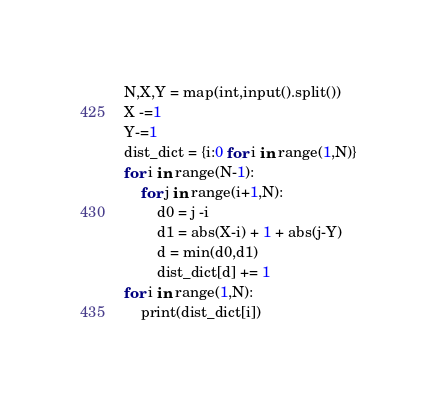<code> <loc_0><loc_0><loc_500><loc_500><_Python_>N,X,Y = map(int,input().split())
X -=1
Y-=1
dist_dict = {i:0 for i in range(1,N)}
for i in range(N-1):
    for j in range(i+1,N):
        d0 = j -i
        d1 = abs(X-i) + 1 + abs(j-Y)
        d = min(d0,d1)
        dist_dict[d] += 1
for i in range(1,N):
    print(dist_dict[i])</code> 